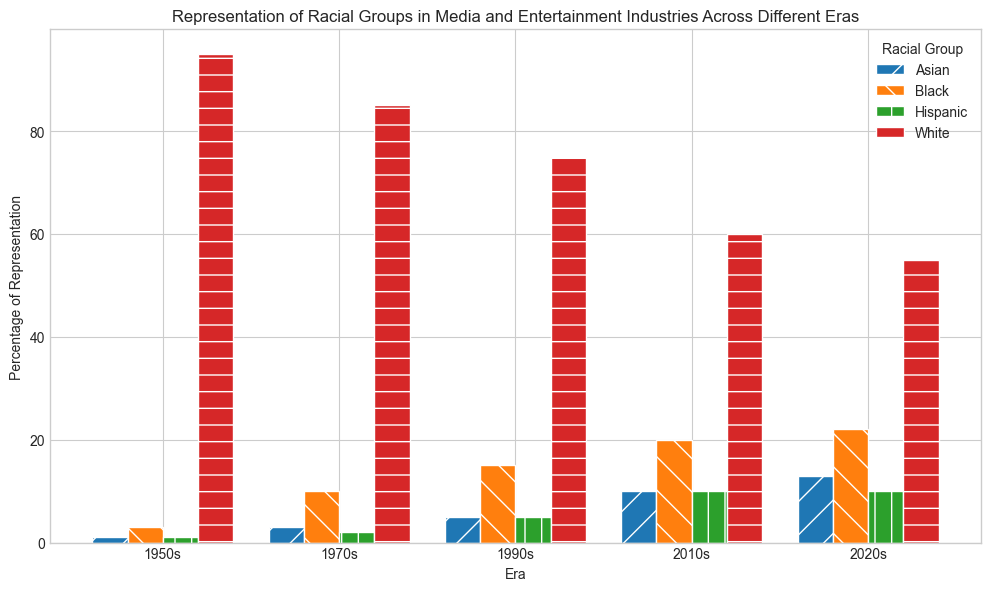What is the trend of White representation from the 1950s to the 2020s? Starting from 95% in the 1950s, White representation consistently declines across each era: 85% in the 1970s, 75% in the 1990s, 60% in the 2010s, and finally 55% in the 2020s.
Answer: Declining trend How did the representation of Black individuals change between the 1950s and the 2020s? In the 1950s, Black representation was 3%. This figure increased to 10% in the 1970s, 15% in the 1990s, 20% in the 2010s, and 22% in the 2020s. There's a clear upward trend over the decades.
Answer: Increased Which racial group showed the most significant increase in representation from the 1950s to the 2020s? Compare the percentages for each racial group across the eras. White: decreased by 40%, Black: increased by 19%, Asian: increased by 12%, Hispanic: increased by 9%. The Black group shows the largest increase.
Answer: Black In which era did Asian representation first reach double digits? Looking at the data, Asian representation hits 10% for the first time in the 2010s.
Answer: 2010s How does the representation of Hispanic individuals in the 2020s compare to that in the 1950s? Hispanic representation was 1% in the 1950s. By the 2020s, it had increased to 10%.
Answer: Increased by 9% Which racial group had the smallest representation in the 1950s? From the data, both Asian and Hispanic groups had the smallest representation at 1% each in the 1950s.
Answer: Asian and Hispanic Was there any era where all racial groups had representation above 5%? Examine each era: Only the 2020s have White (55%), Black (22%), Asian (13%), and Hispanic (10%) all represented above 5%.
Answer: 2020s Compare the percentage of White and Black representation in the 2020s. In the 2020s, White representation is 55%, and Black representation is 22%. The White representation is significantly higher.
Answer: White is higher How does the trend of Asian representation differ from Hispanic representation over the eras? Asian representation increased from 1% in the 1950s to 13% in the 2020s. Hispanic representation increased from 1% in the 1950s to 10% in the 2020s, showing a similar upward trend but less prominent compared to Asians.
Answer: Asian trend is more pronounced How does the combined representation of Black and Hispanic individuals in the 1990s compare to the 2010s? In the 1990s, Black representation is 15% and Hispanic is 5%, totaling 20%. In the 2010s, Black is 20% and Hispanic is 10%, totaling 30%.
Answer: Increased by 10% 